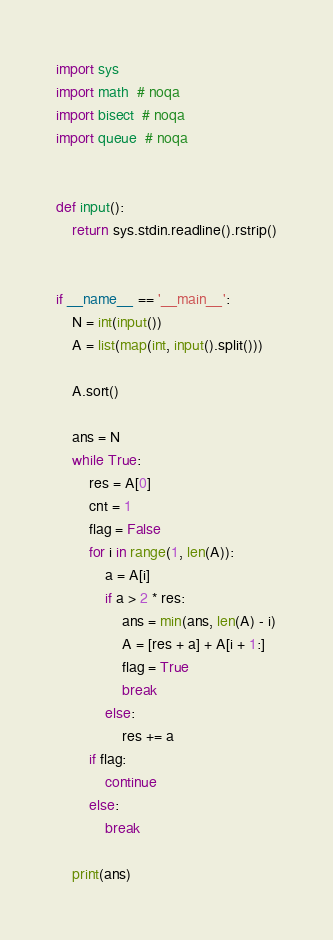<code> <loc_0><loc_0><loc_500><loc_500><_Python_>import sys
import math  # noqa
import bisect  # noqa
import queue  # noqa


def input():
    return sys.stdin.readline().rstrip()


if __name__ == '__main__':
    N = int(input())
    A = list(map(int, input().split()))

    A.sort()

    ans = N
    while True:
        res = A[0]
        cnt = 1
        flag = False
        for i in range(1, len(A)):
            a = A[i]
            if a > 2 * res:
                ans = min(ans, len(A) - i)
                A = [res + a] + A[i + 1:]
                flag = True
                break
            else:
                res += a
        if flag:
            continue
        else:
            break

    print(ans)
</code> 